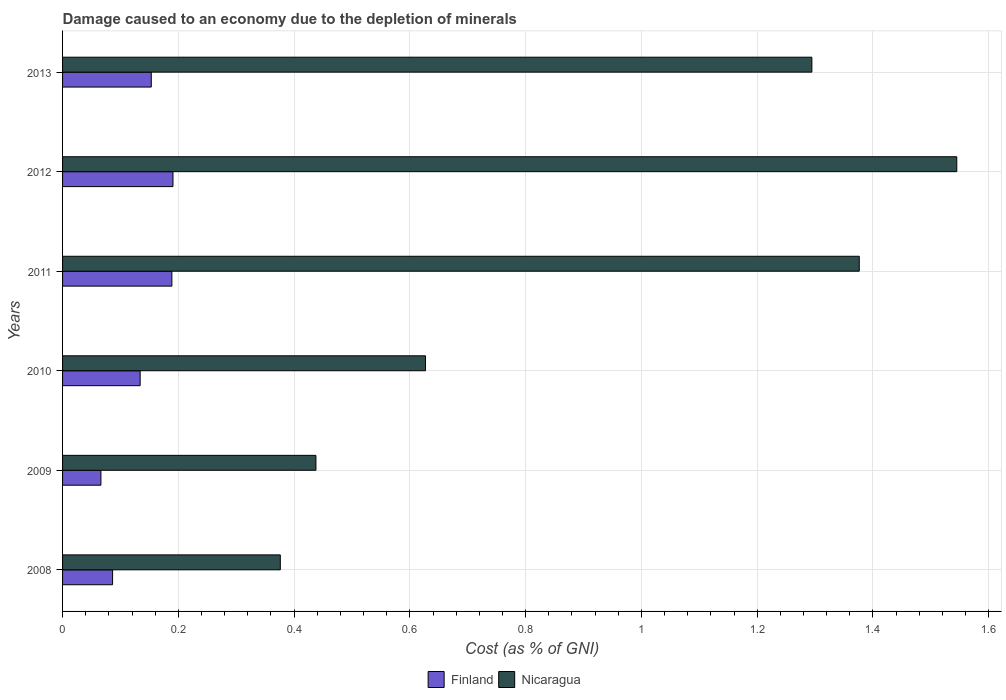How many different coloured bars are there?
Your answer should be very brief. 2. How many groups of bars are there?
Your response must be concise. 6. How many bars are there on the 1st tick from the top?
Offer a very short reply. 2. How many bars are there on the 4th tick from the bottom?
Offer a terse response. 2. What is the label of the 6th group of bars from the top?
Make the answer very short. 2008. What is the cost of damage caused due to the depletion of minerals in Nicaragua in 2013?
Ensure brevity in your answer.  1.29. Across all years, what is the maximum cost of damage caused due to the depletion of minerals in Nicaragua?
Your response must be concise. 1.54. Across all years, what is the minimum cost of damage caused due to the depletion of minerals in Finland?
Offer a very short reply. 0.07. What is the total cost of damage caused due to the depletion of minerals in Nicaragua in the graph?
Your answer should be very brief. 5.66. What is the difference between the cost of damage caused due to the depletion of minerals in Nicaragua in 2008 and that in 2011?
Keep it short and to the point. -1. What is the difference between the cost of damage caused due to the depletion of minerals in Finland in 2009 and the cost of damage caused due to the depletion of minerals in Nicaragua in 2008?
Give a very brief answer. -0.31. What is the average cost of damage caused due to the depletion of minerals in Finland per year?
Provide a short and direct response. 0.14. In the year 2009, what is the difference between the cost of damage caused due to the depletion of minerals in Finland and cost of damage caused due to the depletion of minerals in Nicaragua?
Provide a succinct answer. -0.37. In how many years, is the cost of damage caused due to the depletion of minerals in Finland greater than 1.4000000000000001 %?
Offer a very short reply. 0. What is the ratio of the cost of damage caused due to the depletion of minerals in Nicaragua in 2009 to that in 2010?
Your answer should be compact. 0.7. Is the cost of damage caused due to the depletion of minerals in Nicaragua in 2010 less than that in 2013?
Offer a terse response. Yes. What is the difference between the highest and the second highest cost of damage caused due to the depletion of minerals in Finland?
Keep it short and to the point. 0. What is the difference between the highest and the lowest cost of damage caused due to the depletion of minerals in Nicaragua?
Provide a short and direct response. 1.17. What does the 1st bar from the top in 2012 represents?
Offer a very short reply. Nicaragua. How many bars are there?
Offer a very short reply. 12. What is the difference between two consecutive major ticks on the X-axis?
Give a very brief answer. 0.2. Are the values on the major ticks of X-axis written in scientific E-notation?
Provide a short and direct response. No. Does the graph contain any zero values?
Provide a short and direct response. No. Does the graph contain grids?
Ensure brevity in your answer.  Yes. How are the legend labels stacked?
Offer a terse response. Horizontal. What is the title of the graph?
Provide a succinct answer. Damage caused to an economy due to the depletion of minerals. Does "Palau" appear as one of the legend labels in the graph?
Your answer should be very brief. No. What is the label or title of the X-axis?
Make the answer very short. Cost (as % of GNI). What is the Cost (as % of GNI) in Finland in 2008?
Provide a short and direct response. 0.09. What is the Cost (as % of GNI) of Nicaragua in 2008?
Make the answer very short. 0.38. What is the Cost (as % of GNI) in Finland in 2009?
Give a very brief answer. 0.07. What is the Cost (as % of GNI) of Nicaragua in 2009?
Ensure brevity in your answer.  0.44. What is the Cost (as % of GNI) of Finland in 2010?
Ensure brevity in your answer.  0.13. What is the Cost (as % of GNI) of Nicaragua in 2010?
Your answer should be very brief. 0.63. What is the Cost (as % of GNI) in Finland in 2011?
Offer a very short reply. 0.19. What is the Cost (as % of GNI) in Nicaragua in 2011?
Your answer should be compact. 1.38. What is the Cost (as % of GNI) in Finland in 2012?
Offer a terse response. 0.19. What is the Cost (as % of GNI) in Nicaragua in 2012?
Offer a terse response. 1.54. What is the Cost (as % of GNI) of Finland in 2013?
Provide a succinct answer. 0.15. What is the Cost (as % of GNI) of Nicaragua in 2013?
Keep it short and to the point. 1.29. Across all years, what is the maximum Cost (as % of GNI) in Finland?
Give a very brief answer. 0.19. Across all years, what is the maximum Cost (as % of GNI) in Nicaragua?
Your response must be concise. 1.54. Across all years, what is the minimum Cost (as % of GNI) in Finland?
Your answer should be very brief. 0.07. Across all years, what is the minimum Cost (as % of GNI) in Nicaragua?
Your answer should be compact. 0.38. What is the total Cost (as % of GNI) of Finland in the graph?
Your answer should be very brief. 0.82. What is the total Cost (as % of GNI) of Nicaragua in the graph?
Ensure brevity in your answer.  5.66. What is the difference between the Cost (as % of GNI) of Finland in 2008 and that in 2009?
Your response must be concise. 0.02. What is the difference between the Cost (as % of GNI) in Nicaragua in 2008 and that in 2009?
Ensure brevity in your answer.  -0.06. What is the difference between the Cost (as % of GNI) in Finland in 2008 and that in 2010?
Provide a short and direct response. -0.05. What is the difference between the Cost (as % of GNI) of Nicaragua in 2008 and that in 2010?
Give a very brief answer. -0.25. What is the difference between the Cost (as % of GNI) in Finland in 2008 and that in 2011?
Give a very brief answer. -0.1. What is the difference between the Cost (as % of GNI) in Nicaragua in 2008 and that in 2011?
Give a very brief answer. -1. What is the difference between the Cost (as % of GNI) in Finland in 2008 and that in 2012?
Give a very brief answer. -0.1. What is the difference between the Cost (as % of GNI) in Nicaragua in 2008 and that in 2012?
Your answer should be very brief. -1.17. What is the difference between the Cost (as % of GNI) in Finland in 2008 and that in 2013?
Your response must be concise. -0.07. What is the difference between the Cost (as % of GNI) of Nicaragua in 2008 and that in 2013?
Give a very brief answer. -0.92. What is the difference between the Cost (as % of GNI) of Finland in 2009 and that in 2010?
Your answer should be compact. -0.07. What is the difference between the Cost (as % of GNI) in Nicaragua in 2009 and that in 2010?
Offer a very short reply. -0.19. What is the difference between the Cost (as % of GNI) of Finland in 2009 and that in 2011?
Offer a very short reply. -0.12. What is the difference between the Cost (as % of GNI) of Nicaragua in 2009 and that in 2011?
Provide a succinct answer. -0.94. What is the difference between the Cost (as % of GNI) of Finland in 2009 and that in 2012?
Make the answer very short. -0.12. What is the difference between the Cost (as % of GNI) in Nicaragua in 2009 and that in 2012?
Provide a short and direct response. -1.11. What is the difference between the Cost (as % of GNI) in Finland in 2009 and that in 2013?
Your answer should be compact. -0.09. What is the difference between the Cost (as % of GNI) of Nicaragua in 2009 and that in 2013?
Your answer should be compact. -0.86. What is the difference between the Cost (as % of GNI) in Finland in 2010 and that in 2011?
Offer a very short reply. -0.05. What is the difference between the Cost (as % of GNI) of Nicaragua in 2010 and that in 2011?
Give a very brief answer. -0.75. What is the difference between the Cost (as % of GNI) in Finland in 2010 and that in 2012?
Offer a terse response. -0.06. What is the difference between the Cost (as % of GNI) of Nicaragua in 2010 and that in 2012?
Your answer should be very brief. -0.92. What is the difference between the Cost (as % of GNI) of Finland in 2010 and that in 2013?
Your answer should be compact. -0.02. What is the difference between the Cost (as % of GNI) in Nicaragua in 2010 and that in 2013?
Your response must be concise. -0.67. What is the difference between the Cost (as % of GNI) of Finland in 2011 and that in 2012?
Your answer should be very brief. -0. What is the difference between the Cost (as % of GNI) in Nicaragua in 2011 and that in 2012?
Your answer should be compact. -0.17. What is the difference between the Cost (as % of GNI) in Finland in 2011 and that in 2013?
Your response must be concise. 0.04. What is the difference between the Cost (as % of GNI) of Nicaragua in 2011 and that in 2013?
Your answer should be very brief. 0.08. What is the difference between the Cost (as % of GNI) of Finland in 2012 and that in 2013?
Keep it short and to the point. 0.04. What is the difference between the Cost (as % of GNI) in Nicaragua in 2012 and that in 2013?
Make the answer very short. 0.25. What is the difference between the Cost (as % of GNI) of Finland in 2008 and the Cost (as % of GNI) of Nicaragua in 2009?
Keep it short and to the point. -0.35. What is the difference between the Cost (as % of GNI) of Finland in 2008 and the Cost (as % of GNI) of Nicaragua in 2010?
Give a very brief answer. -0.54. What is the difference between the Cost (as % of GNI) in Finland in 2008 and the Cost (as % of GNI) in Nicaragua in 2011?
Provide a short and direct response. -1.29. What is the difference between the Cost (as % of GNI) in Finland in 2008 and the Cost (as % of GNI) in Nicaragua in 2012?
Offer a terse response. -1.46. What is the difference between the Cost (as % of GNI) in Finland in 2008 and the Cost (as % of GNI) in Nicaragua in 2013?
Make the answer very short. -1.21. What is the difference between the Cost (as % of GNI) of Finland in 2009 and the Cost (as % of GNI) of Nicaragua in 2010?
Provide a short and direct response. -0.56. What is the difference between the Cost (as % of GNI) of Finland in 2009 and the Cost (as % of GNI) of Nicaragua in 2011?
Your response must be concise. -1.31. What is the difference between the Cost (as % of GNI) in Finland in 2009 and the Cost (as % of GNI) in Nicaragua in 2012?
Keep it short and to the point. -1.48. What is the difference between the Cost (as % of GNI) in Finland in 2009 and the Cost (as % of GNI) in Nicaragua in 2013?
Your answer should be very brief. -1.23. What is the difference between the Cost (as % of GNI) in Finland in 2010 and the Cost (as % of GNI) in Nicaragua in 2011?
Keep it short and to the point. -1.24. What is the difference between the Cost (as % of GNI) of Finland in 2010 and the Cost (as % of GNI) of Nicaragua in 2012?
Your answer should be compact. -1.41. What is the difference between the Cost (as % of GNI) in Finland in 2010 and the Cost (as % of GNI) in Nicaragua in 2013?
Keep it short and to the point. -1.16. What is the difference between the Cost (as % of GNI) of Finland in 2011 and the Cost (as % of GNI) of Nicaragua in 2012?
Make the answer very short. -1.36. What is the difference between the Cost (as % of GNI) in Finland in 2011 and the Cost (as % of GNI) in Nicaragua in 2013?
Your response must be concise. -1.11. What is the difference between the Cost (as % of GNI) of Finland in 2012 and the Cost (as % of GNI) of Nicaragua in 2013?
Your response must be concise. -1.1. What is the average Cost (as % of GNI) in Finland per year?
Ensure brevity in your answer.  0.14. What is the average Cost (as % of GNI) in Nicaragua per year?
Provide a short and direct response. 0.94. In the year 2008, what is the difference between the Cost (as % of GNI) of Finland and Cost (as % of GNI) of Nicaragua?
Your answer should be very brief. -0.29. In the year 2009, what is the difference between the Cost (as % of GNI) of Finland and Cost (as % of GNI) of Nicaragua?
Keep it short and to the point. -0.37. In the year 2010, what is the difference between the Cost (as % of GNI) in Finland and Cost (as % of GNI) in Nicaragua?
Your response must be concise. -0.49. In the year 2011, what is the difference between the Cost (as % of GNI) of Finland and Cost (as % of GNI) of Nicaragua?
Make the answer very short. -1.19. In the year 2012, what is the difference between the Cost (as % of GNI) of Finland and Cost (as % of GNI) of Nicaragua?
Your response must be concise. -1.35. In the year 2013, what is the difference between the Cost (as % of GNI) in Finland and Cost (as % of GNI) in Nicaragua?
Your answer should be compact. -1.14. What is the ratio of the Cost (as % of GNI) of Finland in 2008 to that in 2009?
Offer a very short reply. 1.3. What is the ratio of the Cost (as % of GNI) in Nicaragua in 2008 to that in 2009?
Provide a short and direct response. 0.86. What is the ratio of the Cost (as % of GNI) of Finland in 2008 to that in 2010?
Keep it short and to the point. 0.64. What is the ratio of the Cost (as % of GNI) in Nicaragua in 2008 to that in 2010?
Your answer should be very brief. 0.6. What is the ratio of the Cost (as % of GNI) of Finland in 2008 to that in 2011?
Ensure brevity in your answer.  0.46. What is the ratio of the Cost (as % of GNI) in Nicaragua in 2008 to that in 2011?
Your response must be concise. 0.27. What is the ratio of the Cost (as % of GNI) in Finland in 2008 to that in 2012?
Make the answer very short. 0.45. What is the ratio of the Cost (as % of GNI) of Nicaragua in 2008 to that in 2012?
Your answer should be compact. 0.24. What is the ratio of the Cost (as % of GNI) in Finland in 2008 to that in 2013?
Your answer should be compact. 0.56. What is the ratio of the Cost (as % of GNI) of Nicaragua in 2008 to that in 2013?
Your answer should be compact. 0.29. What is the ratio of the Cost (as % of GNI) in Finland in 2009 to that in 2010?
Ensure brevity in your answer.  0.49. What is the ratio of the Cost (as % of GNI) of Nicaragua in 2009 to that in 2010?
Keep it short and to the point. 0.7. What is the ratio of the Cost (as % of GNI) of Finland in 2009 to that in 2011?
Offer a very short reply. 0.35. What is the ratio of the Cost (as % of GNI) of Nicaragua in 2009 to that in 2011?
Give a very brief answer. 0.32. What is the ratio of the Cost (as % of GNI) of Finland in 2009 to that in 2012?
Make the answer very short. 0.35. What is the ratio of the Cost (as % of GNI) in Nicaragua in 2009 to that in 2012?
Your response must be concise. 0.28. What is the ratio of the Cost (as % of GNI) of Finland in 2009 to that in 2013?
Your answer should be very brief. 0.43. What is the ratio of the Cost (as % of GNI) of Nicaragua in 2009 to that in 2013?
Provide a short and direct response. 0.34. What is the ratio of the Cost (as % of GNI) of Finland in 2010 to that in 2011?
Your answer should be very brief. 0.71. What is the ratio of the Cost (as % of GNI) in Nicaragua in 2010 to that in 2011?
Your answer should be very brief. 0.46. What is the ratio of the Cost (as % of GNI) in Finland in 2010 to that in 2012?
Your answer should be compact. 0.7. What is the ratio of the Cost (as % of GNI) in Nicaragua in 2010 to that in 2012?
Provide a succinct answer. 0.41. What is the ratio of the Cost (as % of GNI) in Finland in 2010 to that in 2013?
Give a very brief answer. 0.87. What is the ratio of the Cost (as % of GNI) in Nicaragua in 2010 to that in 2013?
Offer a terse response. 0.48. What is the ratio of the Cost (as % of GNI) of Finland in 2011 to that in 2012?
Ensure brevity in your answer.  0.99. What is the ratio of the Cost (as % of GNI) of Nicaragua in 2011 to that in 2012?
Give a very brief answer. 0.89. What is the ratio of the Cost (as % of GNI) of Finland in 2011 to that in 2013?
Your answer should be compact. 1.23. What is the ratio of the Cost (as % of GNI) of Nicaragua in 2011 to that in 2013?
Give a very brief answer. 1.06. What is the ratio of the Cost (as % of GNI) of Finland in 2012 to that in 2013?
Make the answer very short. 1.24. What is the ratio of the Cost (as % of GNI) in Nicaragua in 2012 to that in 2013?
Your response must be concise. 1.19. What is the difference between the highest and the second highest Cost (as % of GNI) of Finland?
Your answer should be very brief. 0. What is the difference between the highest and the second highest Cost (as % of GNI) of Nicaragua?
Your response must be concise. 0.17. What is the difference between the highest and the lowest Cost (as % of GNI) in Finland?
Provide a succinct answer. 0.12. What is the difference between the highest and the lowest Cost (as % of GNI) in Nicaragua?
Your answer should be very brief. 1.17. 